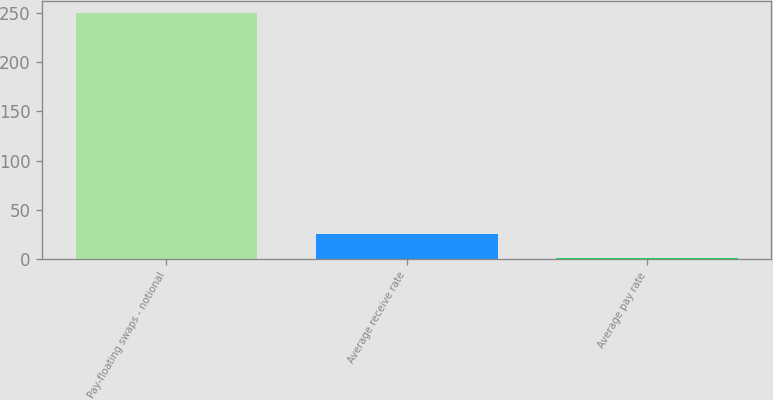Convert chart. <chart><loc_0><loc_0><loc_500><loc_500><bar_chart><fcel>Pay-floating swaps - notional<fcel>Average receive rate<fcel>Average pay rate<nl><fcel>250<fcel>25.45<fcel>0.5<nl></chart> 